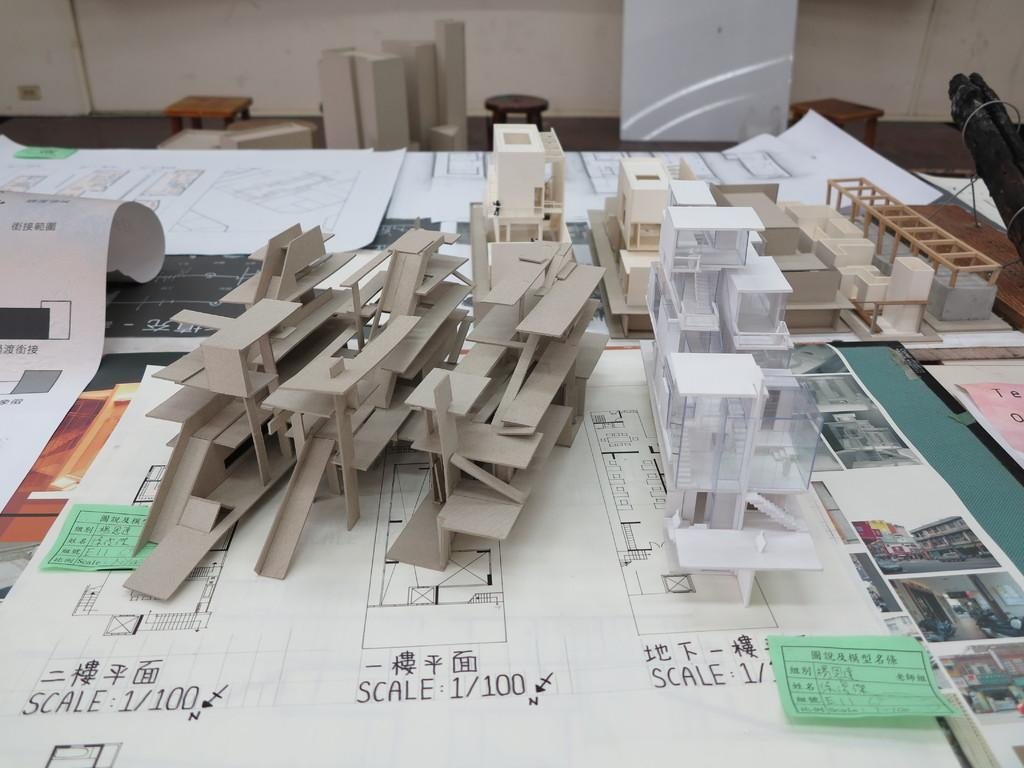<image>
Write a terse but informative summary of the picture. A table with drawings that are a SCALE 1/100. 